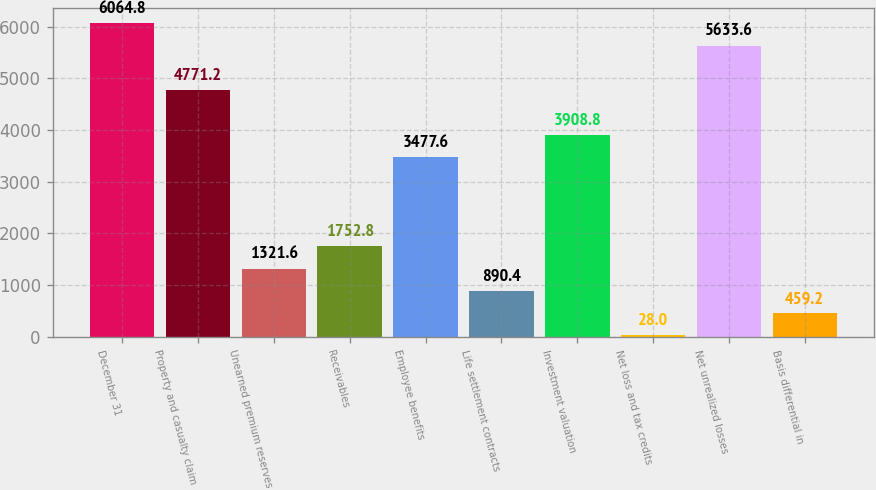Convert chart. <chart><loc_0><loc_0><loc_500><loc_500><bar_chart><fcel>December 31<fcel>Property and casualty claim<fcel>Unearned premium reserves<fcel>Receivables<fcel>Employee benefits<fcel>Life settlement contracts<fcel>Investment valuation<fcel>Net loss and tax credits<fcel>Net unrealized losses<fcel>Basis differential in<nl><fcel>6064.8<fcel>4771.2<fcel>1321.6<fcel>1752.8<fcel>3477.6<fcel>890.4<fcel>3908.8<fcel>28<fcel>5633.6<fcel>459.2<nl></chart> 